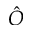<formula> <loc_0><loc_0><loc_500><loc_500>\hat { O }</formula> 